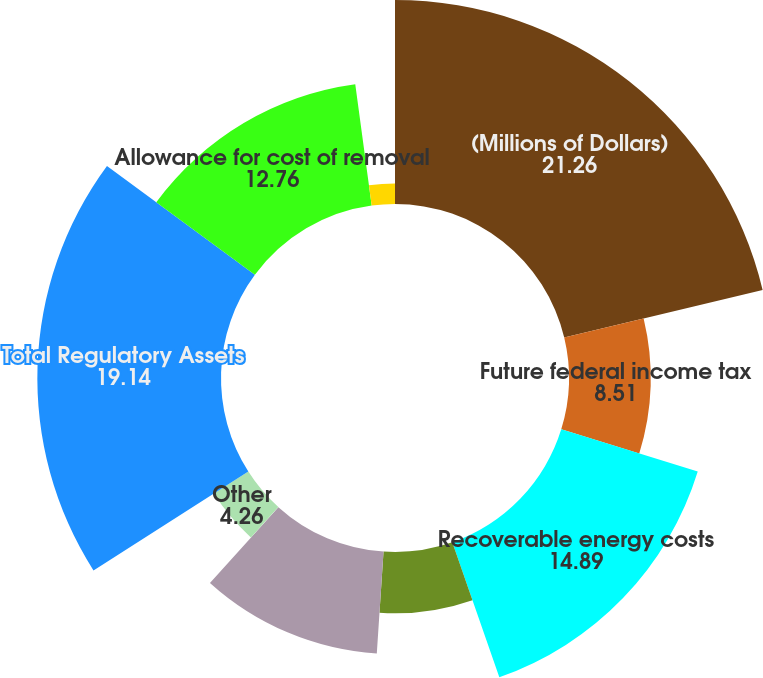Convert chart. <chart><loc_0><loc_0><loc_500><loc_500><pie_chart><fcel>(Millions of Dollars)<fcel>Future federal income tax<fcel>Recoverable energy costs<fcel>Environmental remediation<fcel>Retirement program costs<fcel>Asbestos-related costs<fcel>Other<fcel>Total Regulatory Assets<fcel>Allowance for cost of removal<fcel>Gain on divestiture<nl><fcel>21.26%<fcel>8.51%<fcel>14.89%<fcel>6.39%<fcel>10.64%<fcel>0.01%<fcel>4.26%<fcel>19.14%<fcel>12.76%<fcel>2.14%<nl></chart> 